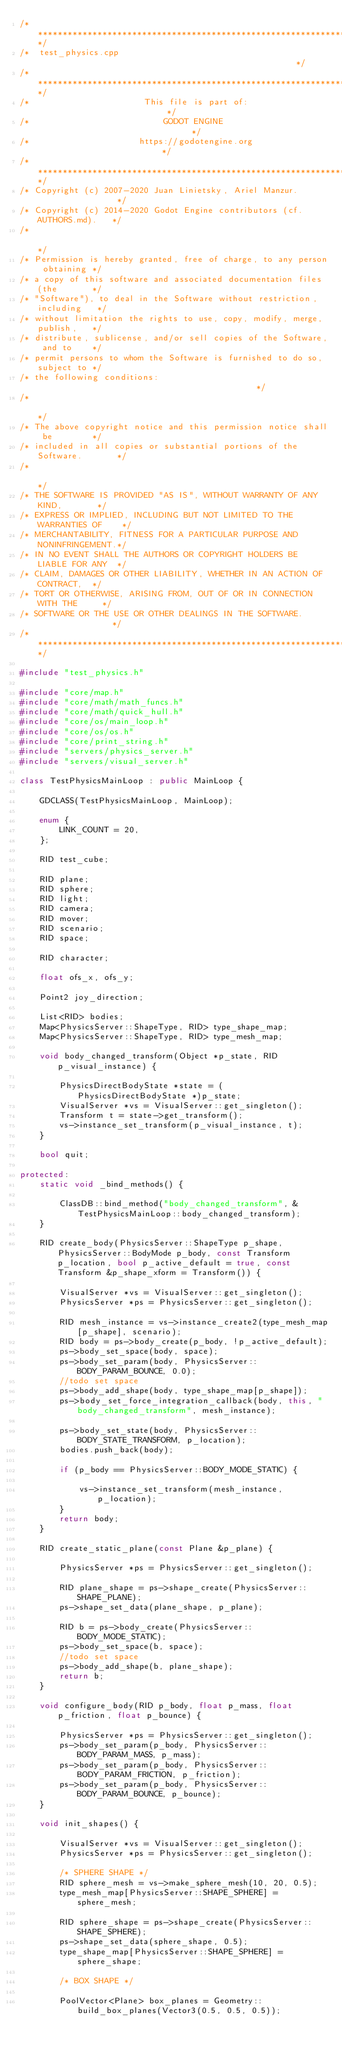<code> <loc_0><loc_0><loc_500><loc_500><_C++_>/*************************************************************************/
/*  test_physics.cpp                                                     */
/*************************************************************************/
/*                       This file is part of:                           */
/*                           GODOT ENGINE                                */
/*                      https://godotengine.org                          */
/*************************************************************************/
/* Copyright (c) 2007-2020 Juan Linietsky, Ariel Manzur.                 */
/* Copyright (c) 2014-2020 Godot Engine contributors (cf. AUTHORS.md).   */
/*                                                                       */
/* Permission is hereby granted, free of charge, to any person obtaining */
/* a copy of this software and associated documentation files (the       */
/* "Software"), to deal in the Software without restriction, including   */
/* without limitation the rights to use, copy, modify, merge, publish,   */
/* distribute, sublicense, and/or sell copies of the Software, and to    */
/* permit persons to whom the Software is furnished to do so, subject to */
/* the following conditions:                                             */
/*                                                                       */
/* The above copyright notice and this permission notice shall be        */
/* included in all copies or substantial portions of the Software.       */
/*                                                                       */
/* THE SOFTWARE IS PROVIDED "AS IS", WITHOUT WARRANTY OF ANY KIND,       */
/* EXPRESS OR IMPLIED, INCLUDING BUT NOT LIMITED TO THE WARRANTIES OF    */
/* MERCHANTABILITY, FITNESS FOR A PARTICULAR PURPOSE AND NONINFRINGEMENT.*/
/* IN NO EVENT SHALL THE AUTHORS OR COPYRIGHT HOLDERS BE LIABLE FOR ANY  */
/* CLAIM, DAMAGES OR OTHER LIABILITY, WHETHER IN AN ACTION OF CONTRACT,  */
/* TORT OR OTHERWISE, ARISING FROM, OUT OF OR IN CONNECTION WITH THE     */
/* SOFTWARE OR THE USE OR OTHER DEALINGS IN THE SOFTWARE.                */
/*************************************************************************/

#include "test_physics.h"

#include "core/map.h"
#include "core/math/math_funcs.h"
#include "core/math/quick_hull.h"
#include "core/os/main_loop.h"
#include "core/os/os.h"
#include "core/print_string.h"
#include "servers/physics_server.h"
#include "servers/visual_server.h"

class TestPhysicsMainLoop : public MainLoop {

	GDCLASS(TestPhysicsMainLoop, MainLoop);

	enum {
		LINK_COUNT = 20,
	};

	RID test_cube;

	RID plane;
	RID sphere;
	RID light;
	RID camera;
	RID mover;
	RID scenario;
	RID space;

	RID character;

	float ofs_x, ofs_y;

	Point2 joy_direction;

	List<RID> bodies;
	Map<PhysicsServer::ShapeType, RID> type_shape_map;
	Map<PhysicsServer::ShapeType, RID> type_mesh_map;

	void body_changed_transform(Object *p_state, RID p_visual_instance) {

		PhysicsDirectBodyState *state = (PhysicsDirectBodyState *)p_state;
		VisualServer *vs = VisualServer::get_singleton();
		Transform t = state->get_transform();
		vs->instance_set_transform(p_visual_instance, t);
	}

	bool quit;

protected:
	static void _bind_methods() {

		ClassDB::bind_method("body_changed_transform", &TestPhysicsMainLoop::body_changed_transform);
	}

	RID create_body(PhysicsServer::ShapeType p_shape, PhysicsServer::BodyMode p_body, const Transform p_location, bool p_active_default = true, const Transform &p_shape_xform = Transform()) {

		VisualServer *vs = VisualServer::get_singleton();
		PhysicsServer *ps = PhysicsServer::get_singleton();

		RID mesh_instance = vs->instance_create2(type_mesh_map[p_shape], scenario);
		RID body = ps->body_create(p_body, !p_active_default);
		ps->body_set_space(body, space);
		ps->body_set_param(body, PhysicsServer::BODY_PARAM_BOUNCE, 0.0);
		//todo set space
		ps->body_add_shape(body, type_shape_map[p_shape]);
		ps->body_set_force_integration_callback(body, this, "body_changed_transform", mesh_instance);

		ps->body_set_state(body, PhysicsServer::BODY_STATE_TRANSFORM, p_location);
		bodies.push_back(body);

		if (p_body == PhysicsServer::BODY_MODE_STATIC) {

			vs->instance_set_transform(mesh_instance, p_location);
		}
		return body;
	}

	RID create_static_plane(const Plane &p_plane) {

		PhysicsServer *ps = PhysicsServer::get_singleton();

		RID plane_shape = ps->shape_create(PhysicsServer::SHAPE_PLANE);
		ps->shape_set_data(plane_shape, p_plane);

		RID b = ps->body_create(PhysicsServer::BODY_MODE_STATIC);
		ps->body_set_space(b, space);
		//todo set space
		ps->body_add_shape(b, plane_shape);
		return b;
	}

	void configure_body(RID p_body, float p_mass, float p_friction, float p_bounce) {

		PhysicsServer *ps = PhysicsServer::get_singleton();
		ps->body_set_param(p_body, PhysicsServer::BODY_PARAM_MASS, p_mass);
		ps->body_set_param(p_body, PhysicsServer::BODY_PARAM_FRICTION, p_friction);
		ps->body_set_param(p_body, PhysicsServer::BODY_PARAM_BOUNCE, p_bounce);
	}

	void init_shapes() {

		VisualServer *vs = VisualServer::get_singleton();
		PhysicsServer *ps = PhysicsServer::get_singleton();

		/* SPHERE SHAPE */
		RID sphere_mesh = vs->make_sphere_mesh(10, 20, 0.5);
		type_mesh_map[PhysicsServer::SHAPE_SPHERE] = sphere_mesh;

		RID sphere_shape = ps->shape_create(PhysicsServer::SHAPE_SPHERE);
		ps->shape_set_data(sphere_shape, 0.5);
		type_shape_map[PhysicsServer::SHAPE_SPHERE] = sphere_shape;

		/* BOX SHAPE */

		PoolVector<Plane> box_planes = Geometry::build_box_planes(Vector3(0.5, 0.5, 0.5));</code> 